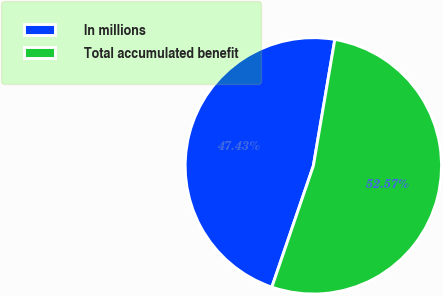Convert chart to OTSL. <chart><loc_0><loc_0><loc_500><loc_500><pie_chart><fcel>In millions<fcel>Total accumulated benefit<nl><fcel>47.43%<fcel>52.57%<nl></chart> 